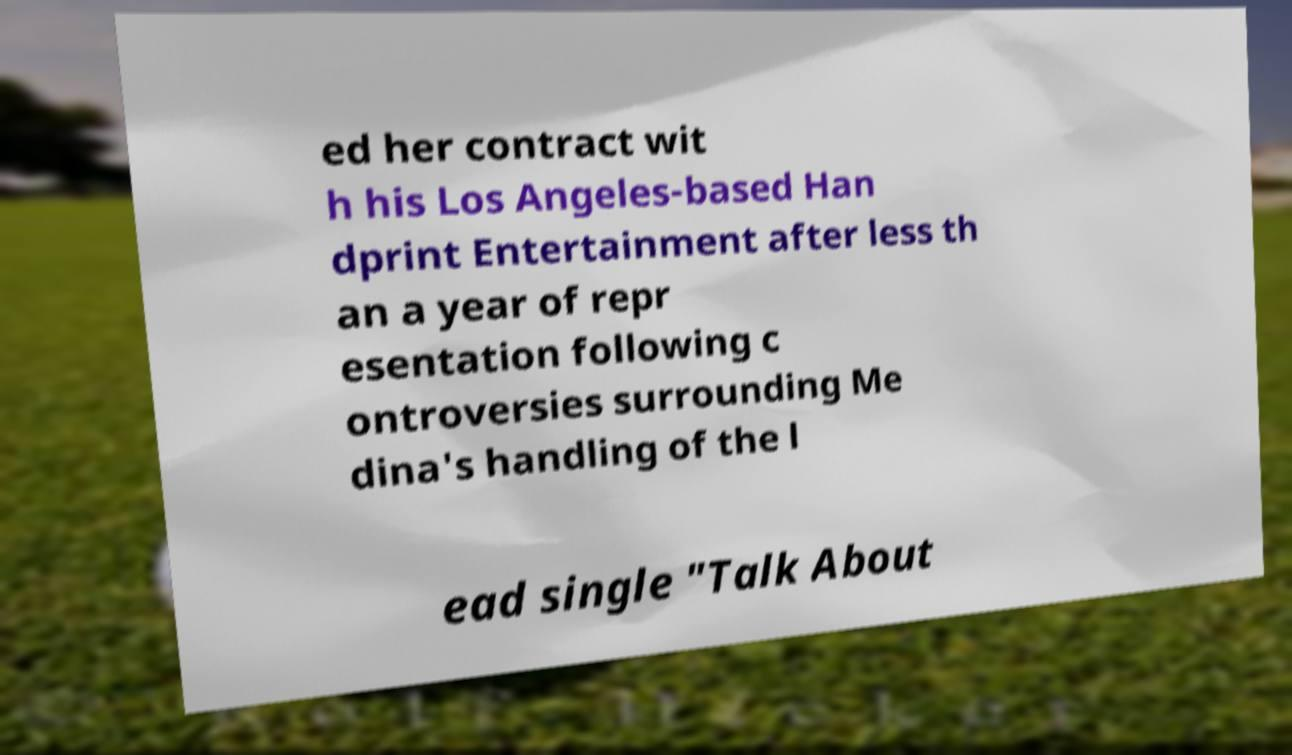Please identify and transcribe the text found in this image. ed her contract wit h his Los Angeles-based Han dprint Entertainment after less th an a year of repr esentation following c ontroversies surrounding Me dina's handling of the l ead single "Talk About 